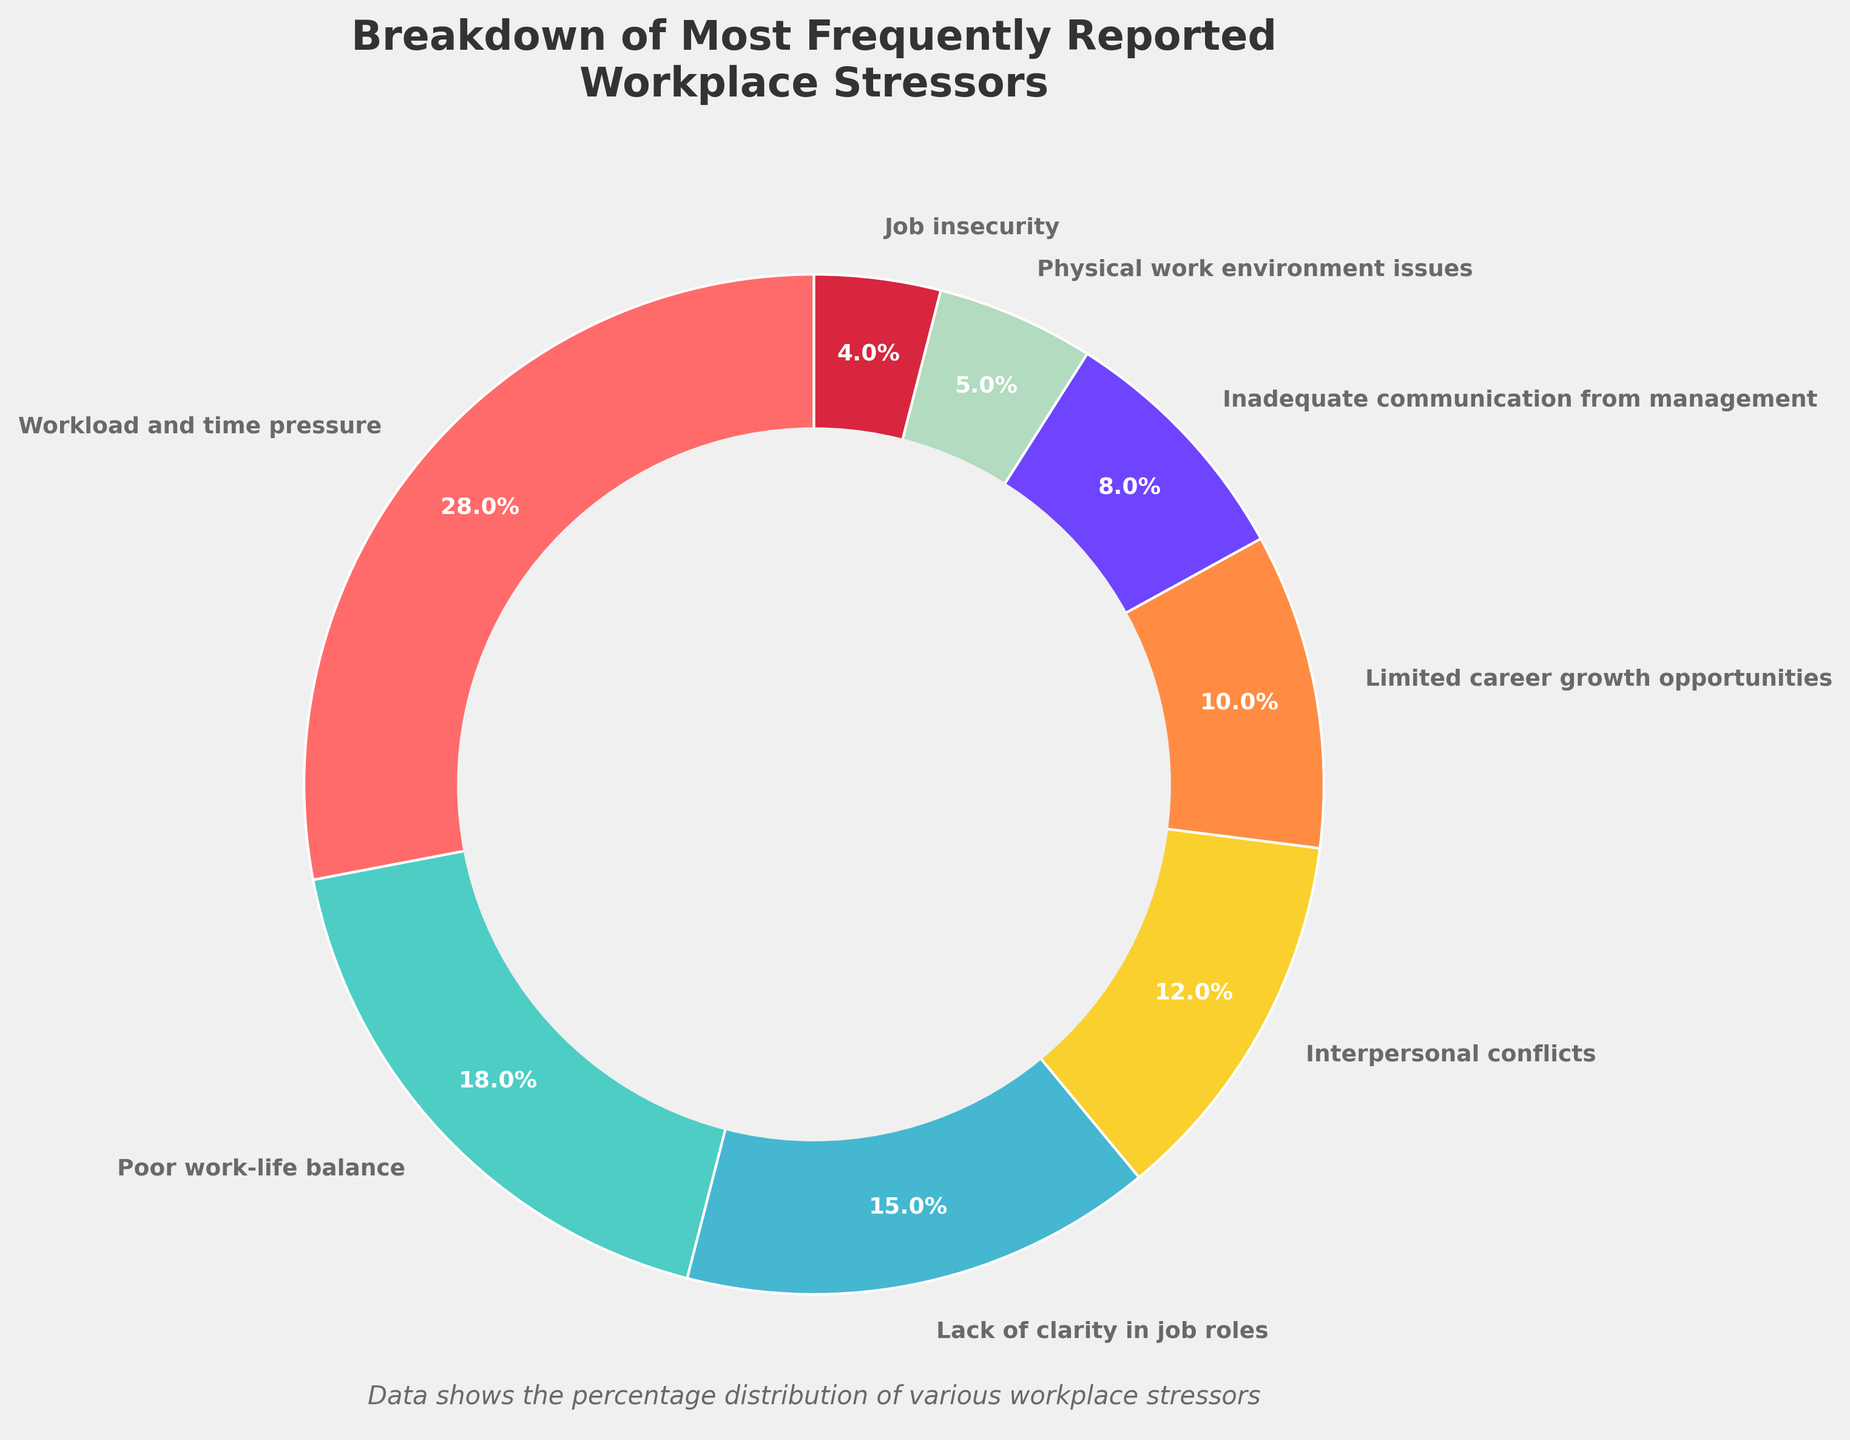What is the highest percentage category in the chart? To find the highest percentage category, look at the chart and identify the category with the largest number. "Workload and time pressure" is marked as 28%, which is the largest percentage.
Answer: Workload and time pressure What is the sum of percentages for the top three stressors? Identify the top three categories: "Workload and time pressure" (28%), "Poor work-life balance" (18%), and "Lack of clarity in job roles" (15%). Sum them up: 28 + 18 + 15 = 61%.
Answer: 61 Which two categories have a combined percentage that is closest to 20%? Check individual percentages and combinations. "Poor work-life balance" (18%) and "Job insecurity" (4%) give 18 + 4 = 22%, which is closest to 20%.
Answer: Poor work-life balance and Job insecurity Does "Inadequate communication from management" contribute more to workplace stress than "Physical work environment issues"? Compare the percentages of the two categories: "Inadequate communication from management" (8%) and "Physical work environment issues" (5%). Since 8% is greater than 5%, it contributes more.
Answer: Yes What is the difference in percentage between "Interpersonal conflicts" and "Limited career growth opportunities"? Identify their percentages: "Interpersonal conflicts" (12%) and "Limited career growth opportunities" (10%). The difference is: 12 - 10 = 2%.
Answer: 2 What percentage of respondents reported stressors other than the top category? Subtract the top category "Workload and time pressure" (28%) from the total 100%: 100 - 28 = 72%.
Answer: 72 Which category, visualized in purple, contributes to workplace stress? The wedge visualized in purple represents the 8% segment, which corresponds to "Inadequate communication from management".
Answer: Inadequate communication from management Which categories together make up less than a quarter of the total percentage? Identify categories summing up to less than 25%: "Physical work environment issues" (5%), and "Job insecurity" (4%), which together sum to 9%. "Inadequate communication from management" (8%) can be added to get 17%. Finally, "Limited career growth opportunities" (10%) takes it to 27%. Only the first three (5% + 4% + 8%) meet the requirement.
Answer: Physical work environment issues and Job insecurity and Inadequate communication from management What is the average percentage of the three least-reported categories? Identify the three least-reported categories: "Physical work environment issues" (5%), and "Job insecurity" (4%). Their sum is: 5 + 4 = 9%. There are two categories, so the average is: 9 / 2 = 4.5%.
Answer: 4.5% 